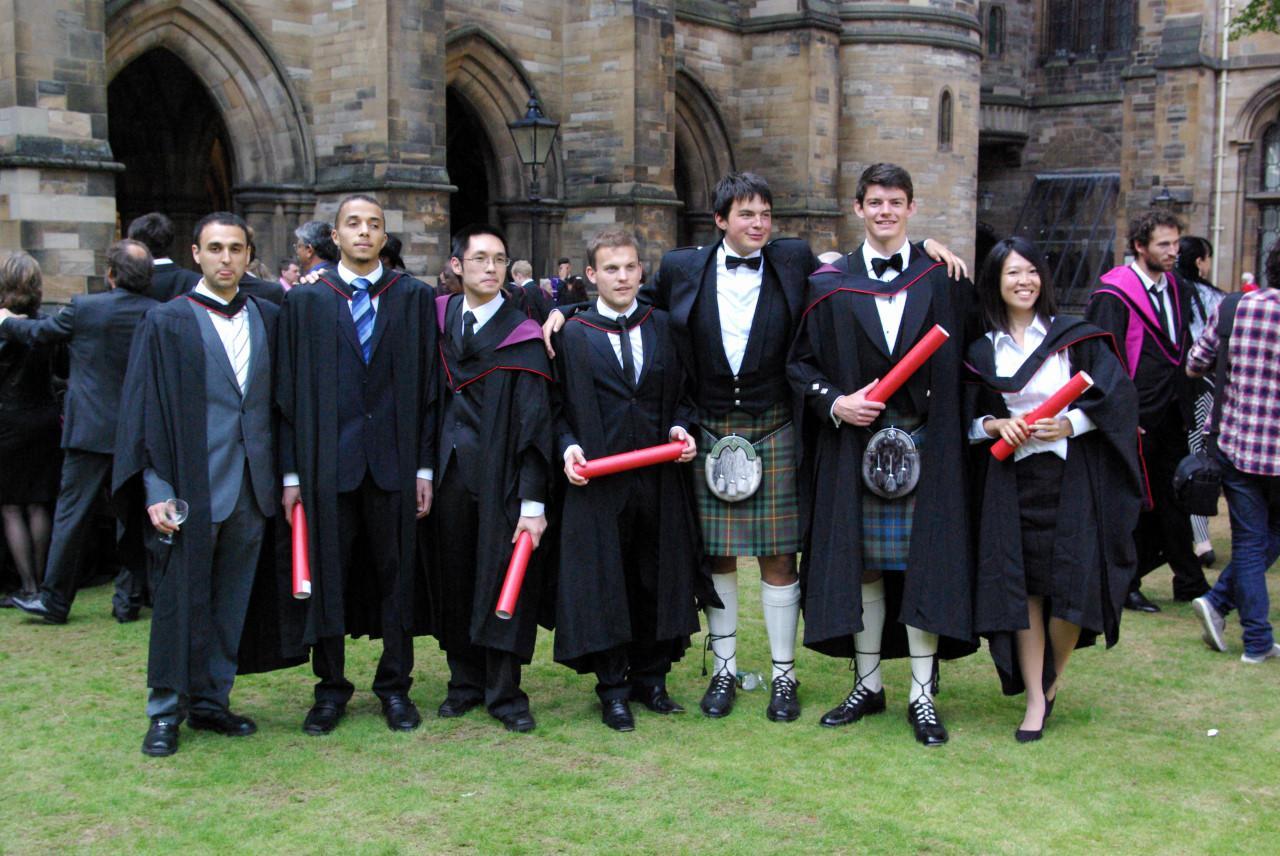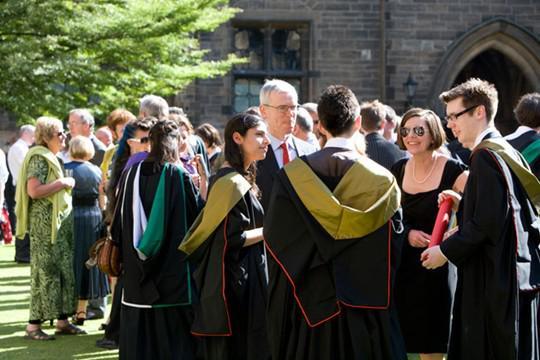The first image is the image on the left, the second image is the image on the right. Examine the images to the left and right. Is the description "At least four people hold red tube shapes and wear black robes in the foreground of one image." accurate? Answer yes or no. Yes. The first image is the image on the left, the second image is the image on the right. For the images shown, is this caption "At least four graduates are holding red diploma tubes." true? Answer yes or no. Yes. 